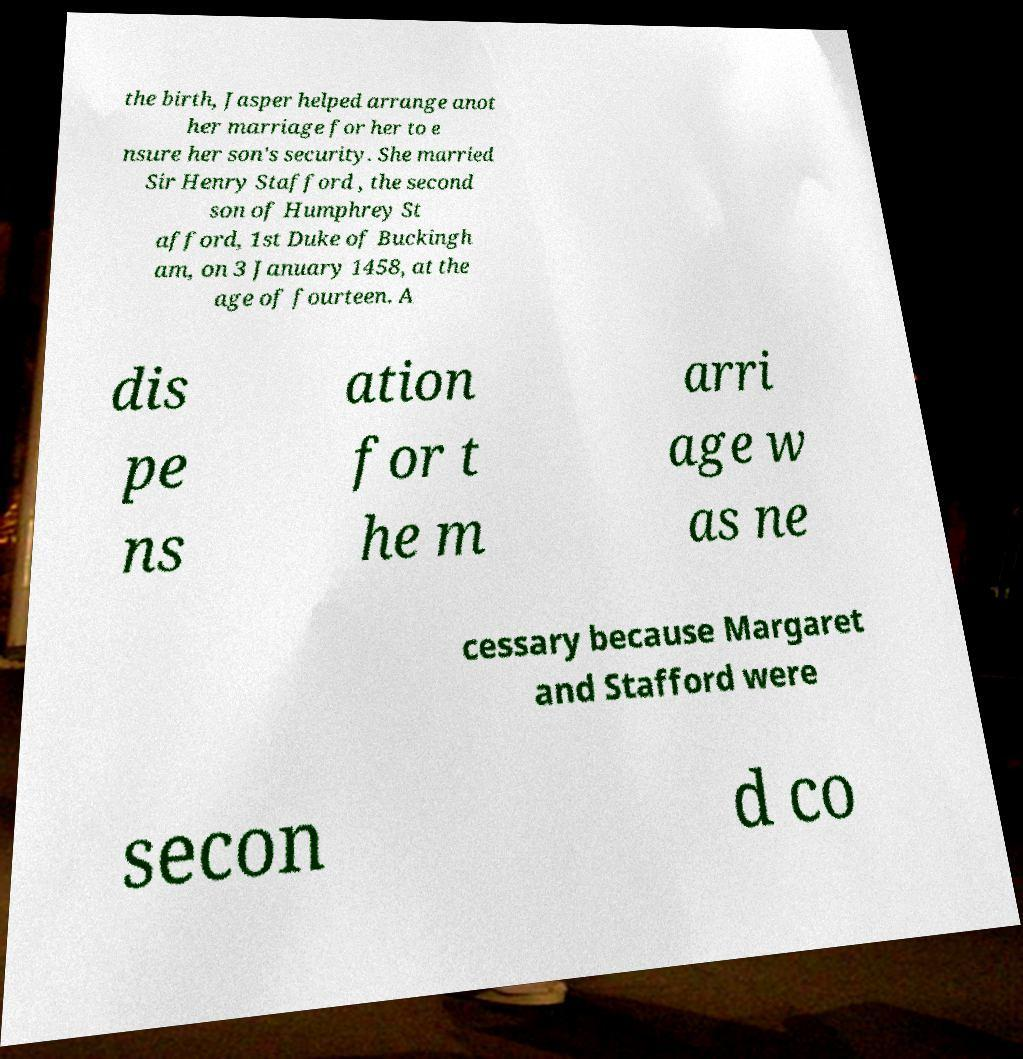I need the written content from this picture converted into text. Can you do that? the birth, Jasper helped arrange anot her marriage for her to e nsure her son's security. She married Sir Henry Stafford , the second son of Humphrey St afford, 1st Duke of Buckingh am, on 3 January 1458, at the age of fourteen. A dis pe ns ation for t he m arri age w as ne cessary because Margaret and Stafford were secon d co 